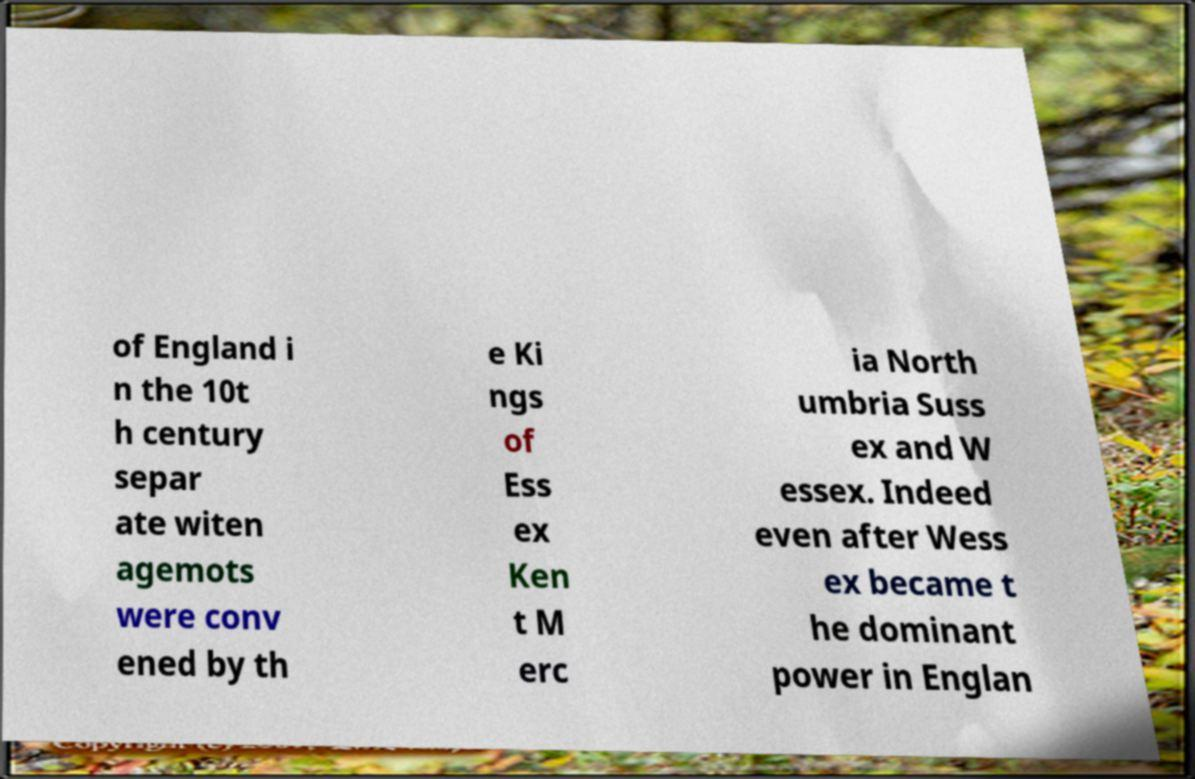Please read and relay the text visible in this image. What does it say? of England i n the 10t h century separ ate witen agemots were conv ened by th e Ki ngs of Ess ex Ken t M erc ia North umbria Suss ex and W essex. Indeed even after Wess ex became t he dominant power in Englan 